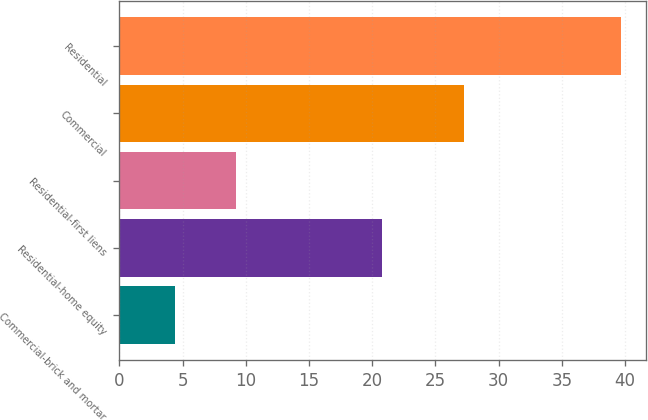<chart> <loc_0><loc_0><loc_500><loc_500><bar_chart><fcel>Commercial-brick and mortar<fcel>Residential-home equity<fcel>Residential-first liens<fcel>Commercial<fcel>Residential<nl><fcel>4.4<fcel>20.8<fcel>9.2<fcel>27.3<fcel>39.7<nl></chart> 